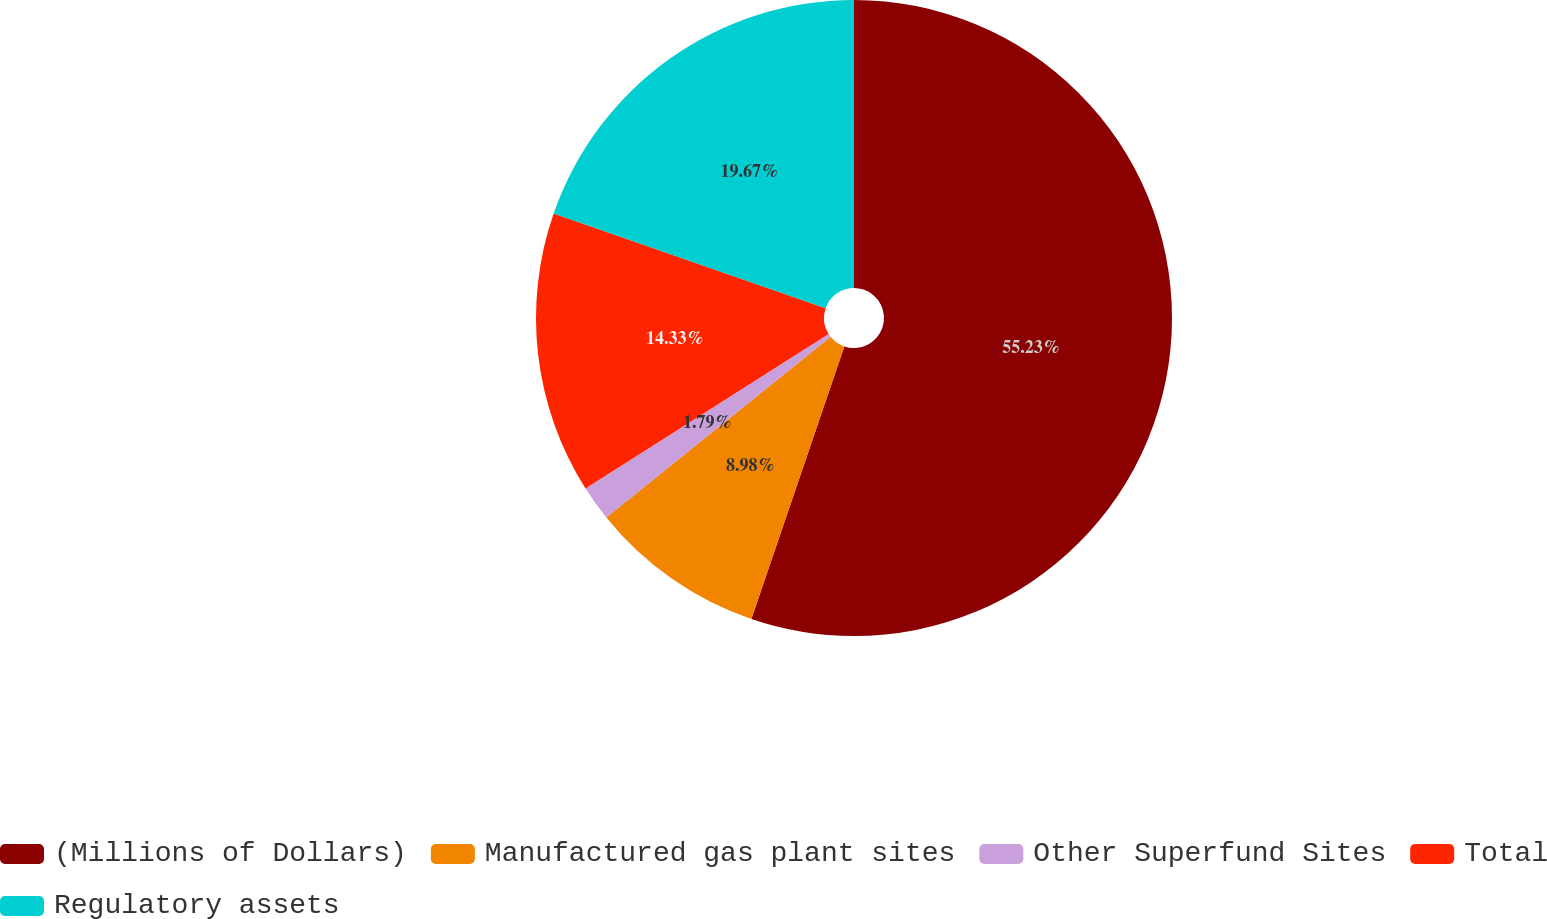<chart> <loc_0><loc_0><loc_500><loc_500><pie_chart><fcel>(Millions of Dollars)<fcel>Manufactured gas plant sites<fcel>Other Superfund Sites<fcel>Total<fcel>Regulatory assets<nl><fcel>55.23%<fcel>8.98%<fcel>1.79%<fcel>14.33%<fcel>19.67%<nl></chart> 